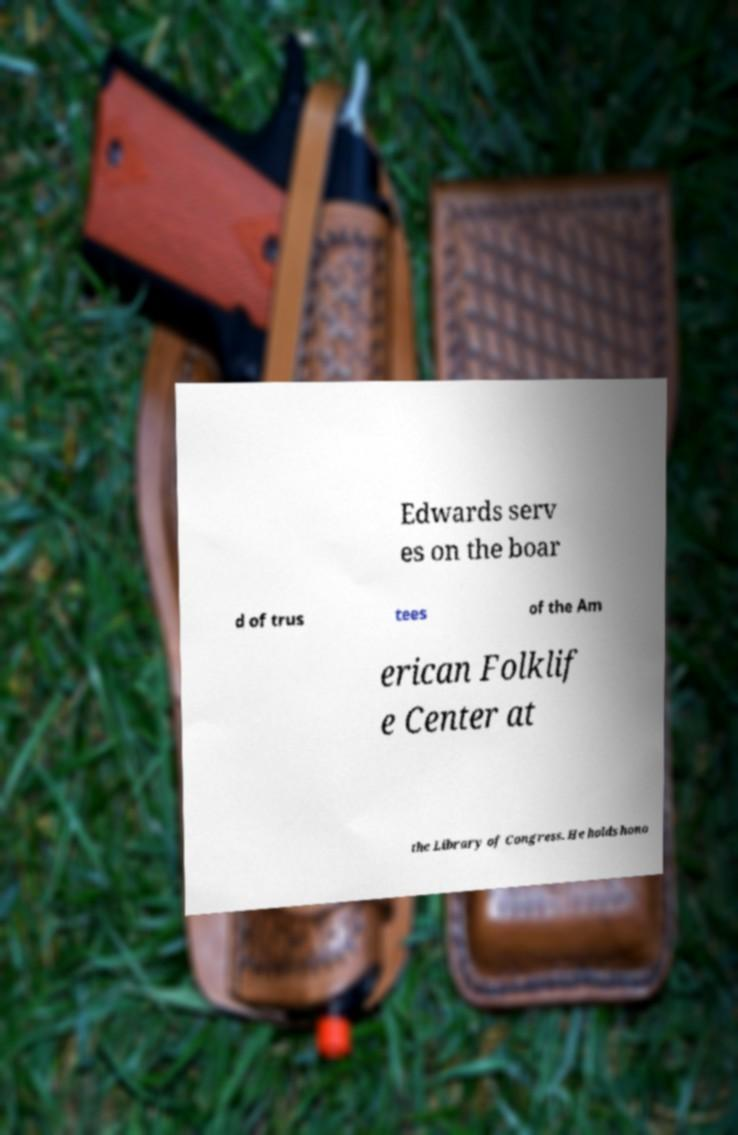Can you read and provide the text displayed in the image?This photo seems to have some interesting text. Can you extract and type it out for me? Edwards serv es on the boar d of trus tees of the Am erican Folklif e Center at the Library of Congress. He holds hono 